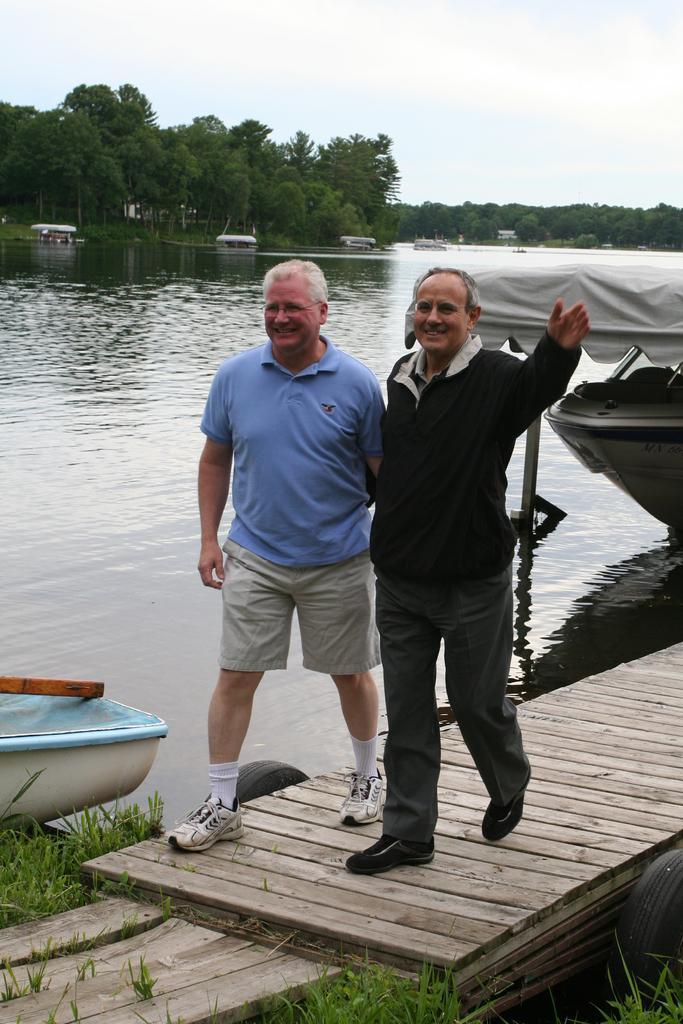Please provide a concise description of this image. In this picture, we see two men are standing on the wooden bridge. Both of them are smiling and they are posing for the photo. At the bottom, we see the grass. On the left side, we see a boat in white and blue color. Behind them, we see a boat. In the middle, we see water and this water might be in the lake. There are trees and the boats in the background. At the top, we see the sky. 